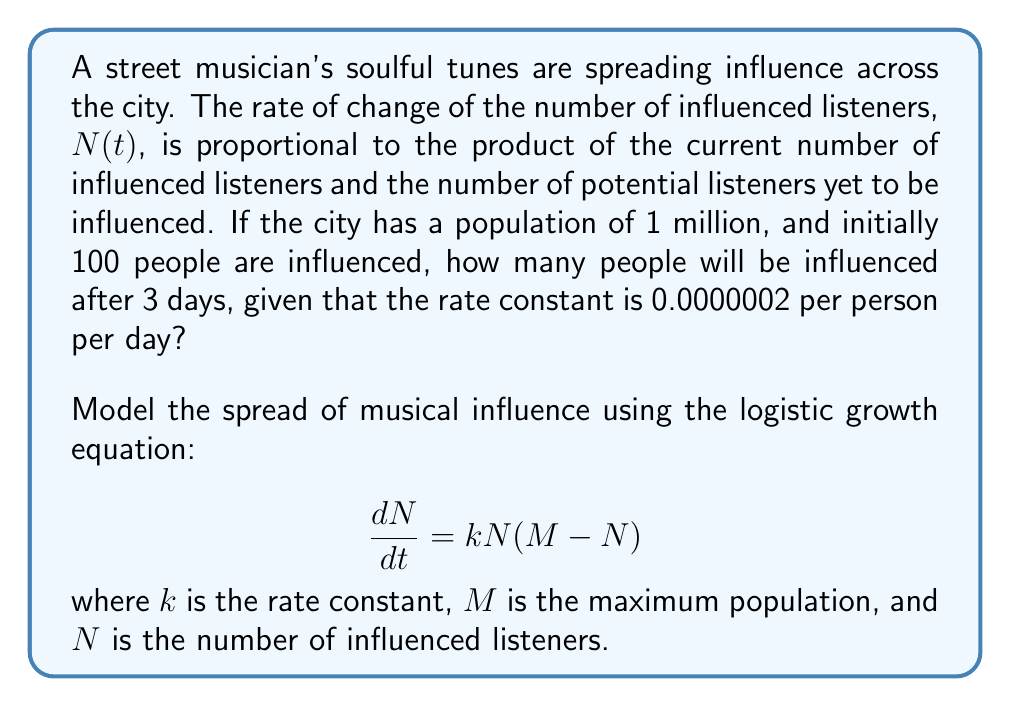Show me your answer to this math problem. Let's solve this problem step by step:

1) We are given:
   - Initial number of influenced listeners, $N_0 = 100$
   - Maximum population, $M = 1,000,000$
   - Rate constant, $k = 0.0000002$ per person per day
   - Time, $t = 3$ days

2) The logistic growth equation solution is:

   $$N(t) = \frac{M}{1 + (\frac{M}{N_0} - 1)e^{-kMt}}$$

3) Let's substitute our values:

   $$N(3) = \frac{1,000,000}{1 + (\frac{1,000,000}{100} - 1)e^{-0.0000002 \cdot 1,000,000 \cdot 3}}$$

4) Simplify:

   $$N(3) = \frac{1,000,000}{1 + (9,999)e^{-0.6}}$$

5) Calculate $e^{-0.6} \approx 0.5488$:

   $$N(3) = \frac{1,000,000}{1 + 9,999 \cdot 0.5488} \approx \frac{1,000,000}{5,487.88}$$

6) Solve:

   $$N(3) \approx 182.22$$

7) Since we're dealing with people, we round to the nearest whole number:

   $$N(3) \approx 182$$

Therefore, after 3 days, approximately 182 people will be influenced by the street musician's soulful tunes.
Answer: 182 people 